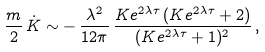Convert formula to latex. <formula><loc_0><loc_0><loc_500><loc_500>\frac { m } { 2 } \, \dot { K } \sim - \, \frac { \lambda ^ { 2 } } { 1 2 \pi } \, \frac { K e ^ { 2 \lambda \tau } \, ( K e ^ { 2 \lambda \tau } + 2 ) } { ( K e ^ { 2 \lambda \tau } + 1 ) ^ { 2 } } \, ,</formula> 